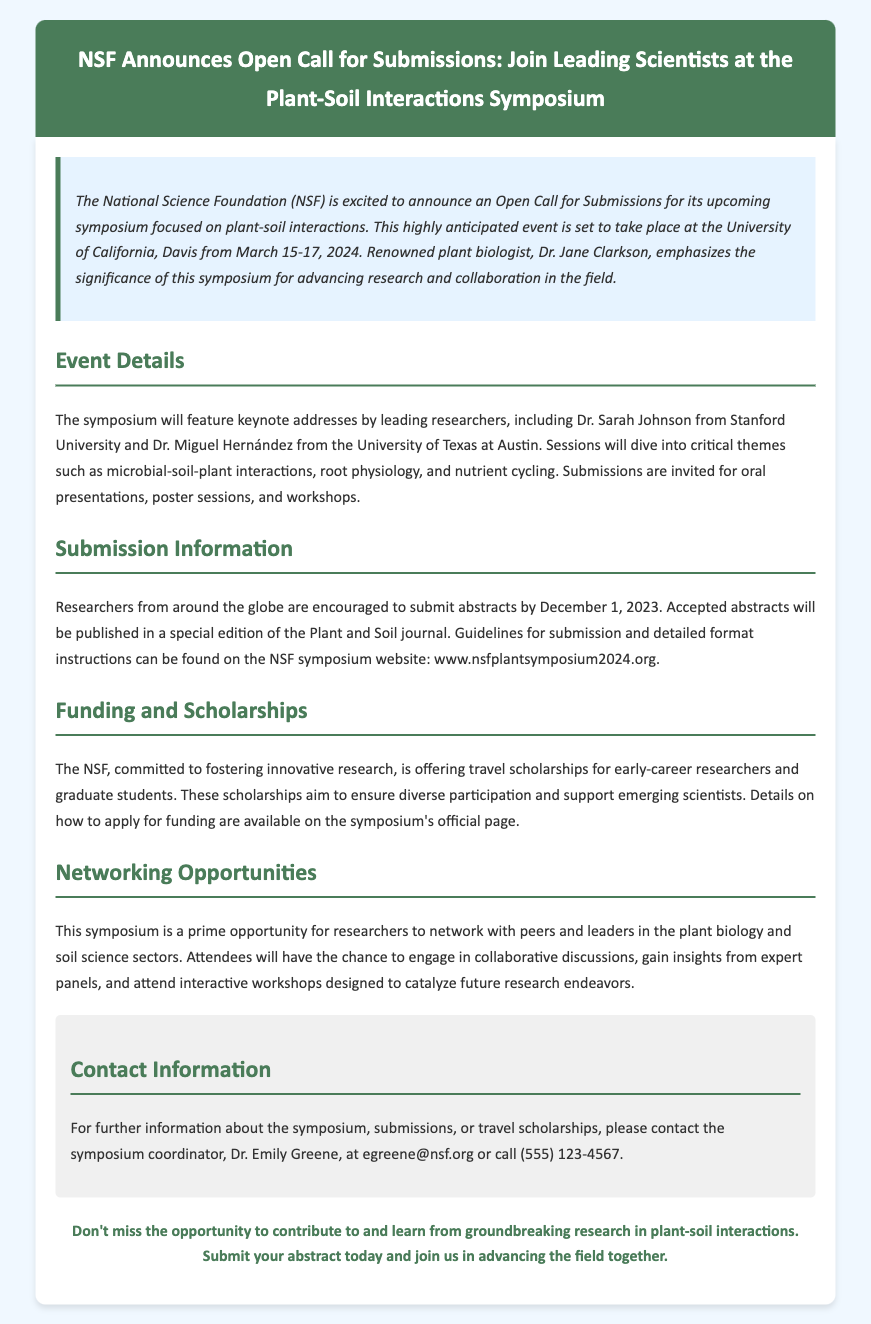What are the dates of the symposium? The dates of the symposium are specified in the document as March 15-17, 2024.
Answer: March 15-17, 2024 Who is one of the keynote speakers? The document lists Dr. Sarah Johnson from Stanford University as one of the keynote speakers.
Answer: Dr. Sarah Johnson What is the submission deadline for abstracts? According to the document, the submission deadline for abstracts is December 1, 2023.
Answer: December 1, 2023 What journal will publish the accepted abstracts? The document mentions that accepted abstracts will be published in a special edition of the Plant and Soil journal.
Answer: Plant and Soil journal What type of scholarships does the NSF offer? The document states that the NSF offers travel scholarships for early-career researchers and graduate students.
Answer: Travel scholarships Why is the symposium important? The document emphasizes that the symposium is significant for advancing research and collaboration in the field of plant-soil interactions.
Answer: Advancing research and collaboration How can attendees contact for more information? The document provides Dr. Emily Greene's email address and phone number for further information.
Answer: egreene@nsf.org What topics will be covered at the symposium? The document outlines that the sessions will cover microbial-soil-plant interactions, root physiology, and nutrient cycling.
Answer: Microbial-soil-plant interactions, root physiology, and nutrient cycling What opportunity does the symposium provide for researchers? The document states that the symposium offers networking opportunities with peers and leaders in the plant biology and soil science sectors.
Answer: Networking opportunities 